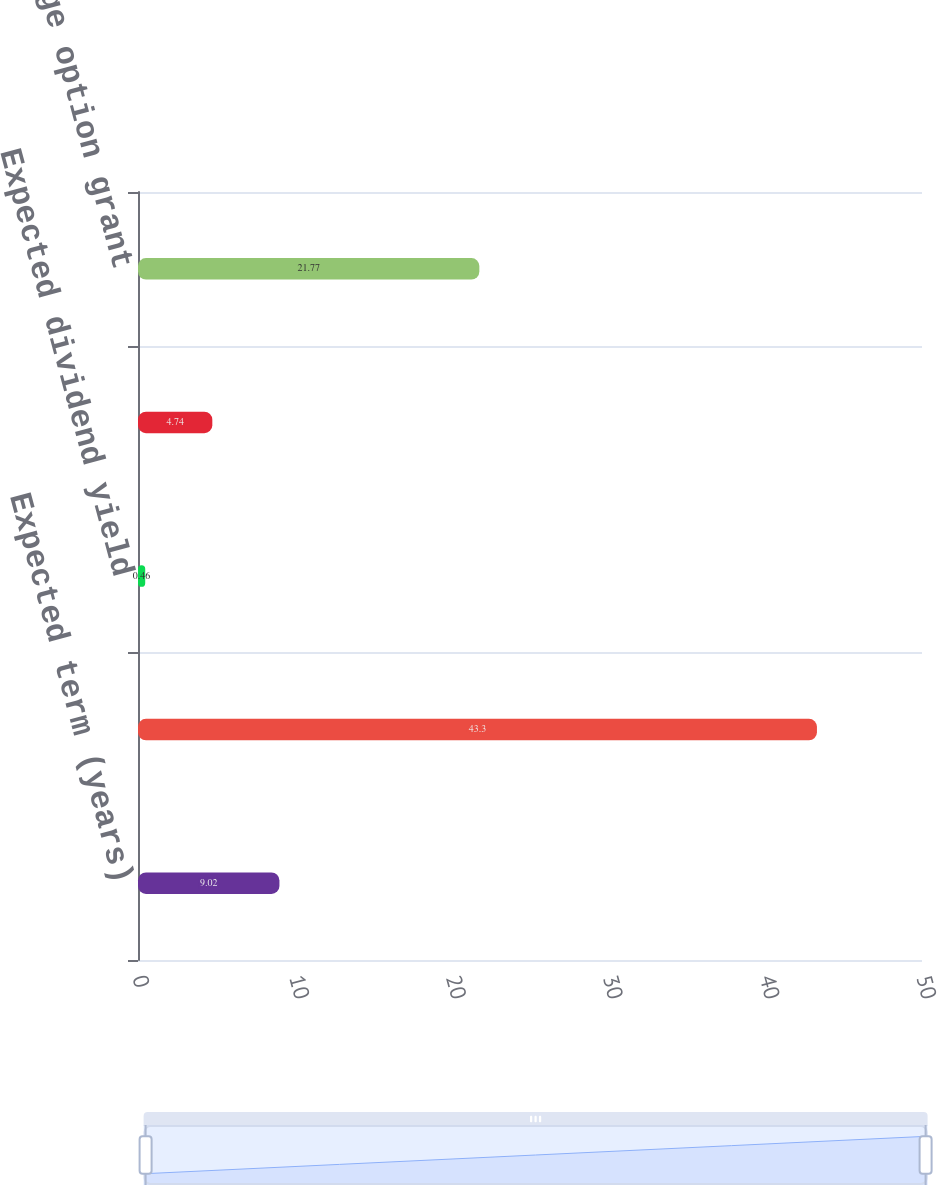Convert chart to OTSL. <chart><loc_0><loc_0><loc_500><loc_500><bar_chart><fcel>Expected term (years)<fcel>Expected volatility<fcel>Expected dividend yield<fcel>Risk-free interest rate<fcel>Weighted-average option grant<nl><fcel>9.02<fcel>43.3<fcel>0.46<fcel>4.74<fcel>21.77<nl></chart> 